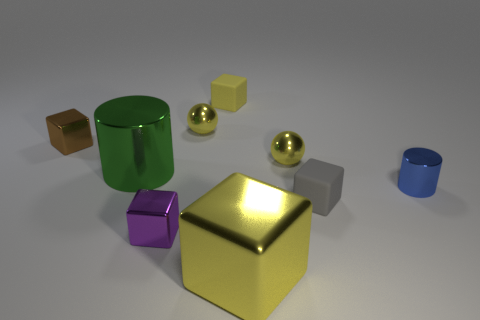Do the tiny cylinder and the big metallic cube have the same color?
Ensure brevity in your answer.  No. What number of objects are either yellow shiny things behind the brown cube or large metal cylinders?
Your answer should be compact. 2. How many objects are to the left of the metallic thing that is right of the rubber object that is to the right of the small yellow rubber block?
Ensure brevity in your answer.  8. What is the shape of the small yellow thing that is right of the yellow metal block that is in front of the small yellow sphere in front of the small brown object?
Make the answer very short. Sphere. What number of other objects are the same color as the big cylinder?
Ensure brevity in your answer.  0. What shape is the small purple shiny object that is left of the small rubber block behind the large green thing?
Provide a succinct answer. Cube. There is a small metallic cylinder; how many big metallic cubes are in front of it?
Give a very brief answer. 1. Is there a blue cylinder that has the same material as the brown cube?
Give a very brief answer. Yes. What is the material of the gray cube that is the same size as the blue object?
Keep it short and to the point. Rubber. There is a cube that is both in front of the yellow matte object and behind the small blue cylinder; how big is it?
Your answer should be compact. Small. 